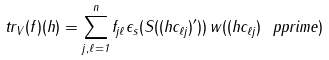Convert formula to latex. <formula><loc_0><loc_0><loc_500><loc_500>\ t r _ { V } ( f ) ( h ) = \sum _ { j , \ell = 1 } ^ { n } f _ { j \ell } \epsilon _ { s } ( S ( { ( h c _ { \ell j } ) } ^ { \prime } ) ) \, w ( { ( h c _ { \ell j } ) } ^ { \ } p p r i m e )</formula> 